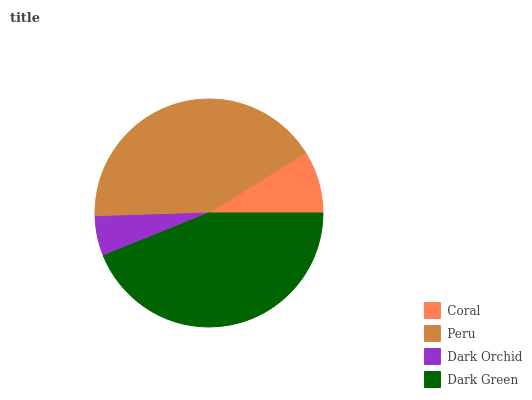Is Dark Orchid the minimum?
Answer yes or no. Yes. Is Dark Green the maximum?
Answer yes or no. Yes. Is Peru the minimum?
Answer yes or no. No. Is Peru the maximum?
Answer yes or no. No. Is Peru greater than Coral?
Answer yes or no. Yes. Is Coral less than Peru?
Answer yes or no. Yes. Is Coral greater than Peru?
Answer yes or no. No. Is Peru less than Coral?
Answer yes or no. No. Is Peru the high median?
Answer yes or no. Yes. Is Coral the low median?
Answer yes or no. Yes. Is Dark Green the high median?
Answer yes or no. No. Is Dark Orchid the low median?
Answer yes or no. No. 